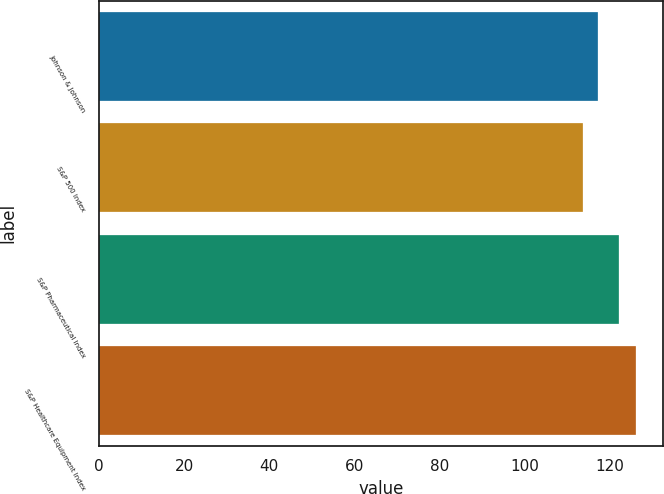Convert chart to OTSL. <chart><loc_0><loc_0><loc_500><loc_500><bar_chart><fcel>Johnson & Johnson<fcel>S&P 500 Index<fcel>S&P Pharmaceutical Index<fcel>S&P Healthcare Equipment Index<nl><fcel>117.34<fcel>113.68<fcel>122.22<fcel>126.28<nl></chart> 